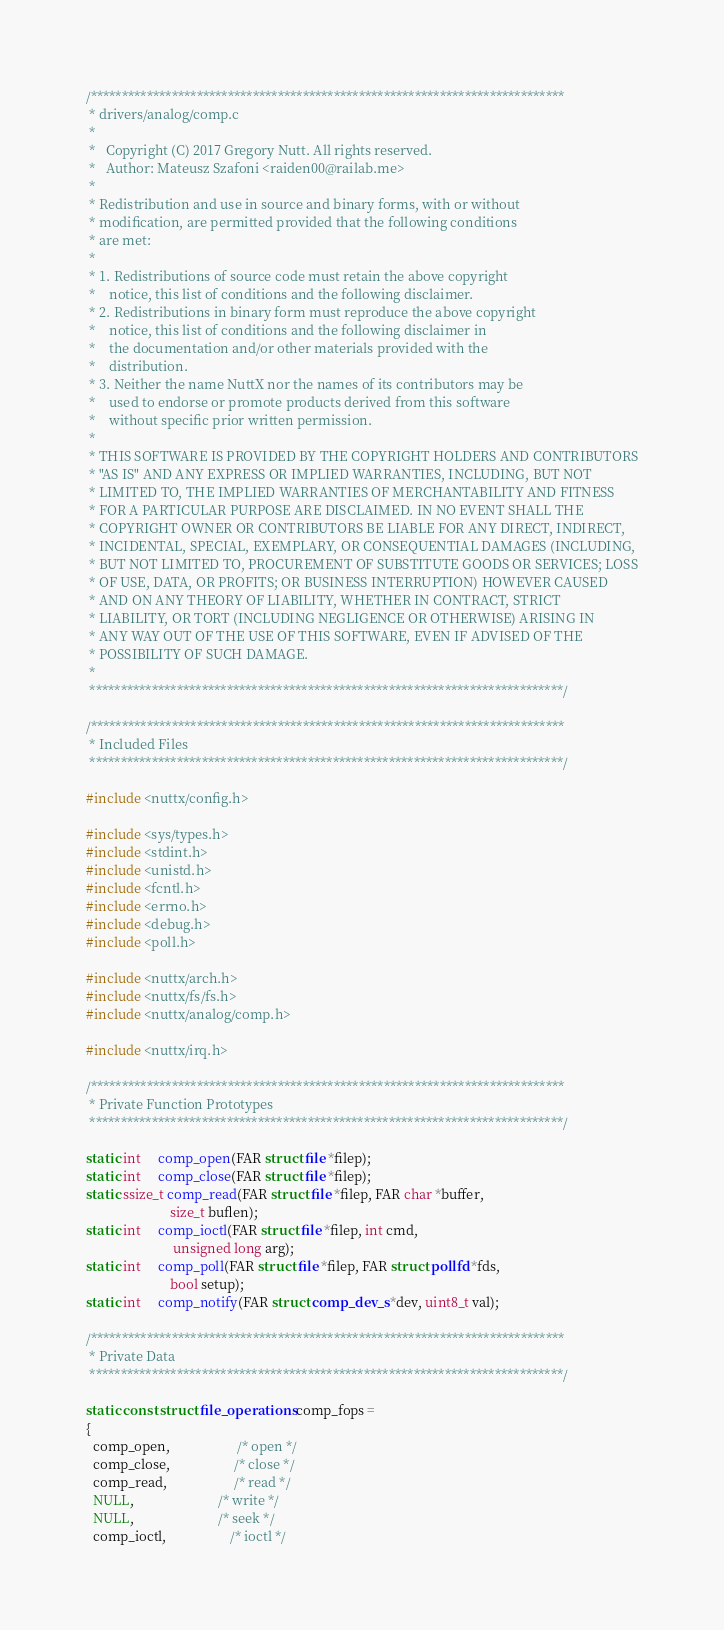Convert code to text. <code><loc_0><loc_0><loc_500><loc_500><_C_>/****************************************************************************
 * drivers/analog/comp.c
 *
 *   Copyright (C) 2017 Gregory Nutt. All rights reserved.
 *   Author: Mateusz Szafoni <raiden00@railab.me>
 *
 * Redistribution and use in source and binary forms, with or without
 * modification, are permitted provided that the following conditions
 * are met:
 *
 * 1. Redistributions of source code must retain the above copyright
 *    notice, this list of conditions and the following disclaimer.
 * 2. Redistributions in binary form must reproduce the above copyright
 *    notice, this list of conditions and the following disclaimer in
 *    the documentation and/or other materials provided with the
 *    distribution.
 * 3. Neither the name NuttX nor the names of its contributors may be
 *    used to endorse or promote products derived from this software
 *    without specific prior written permission.
 *
 * THIS SOFTWARE IS PROVIDED BY THE COPYRIGHT HOLDERS AND CONTRIBUTORS
 * "AS IS" AND ANY EXPRESS OR IMPLIED WARRANTIES, INCLUDING, BUT NOT
 * LIMITED TO, THE IMPLIED WARRANTIES OF MERCHANTABILITY AND FITNESS
 * FOR A PARTICULAR PURPOSE ARE DISCLAIMED. IN NO EVENT SHALL THE
 * COPYRIGHT OWNER OR CONTRIBUTORS BE LIABLE FOR ANY DIRECT, INDIRECT,
 * INCIDENTAL, SPECIAL, EXEMPLARY, OR CONSEQUENTIAL DAMAGES (INCLUDING,
 * BUT NOT LIMITED TO, PROCUREMENT OF SUBSTITUTE GOODS OR SERVICES; LOSS
 * OF USE, DATA, OR PROFITS; OR BUSINESS INTERRUPTION) HOWEVER CAUSED
 * AND ON ANY THEORY OF LIABILITY, WHETHER IN CONTRACT, STRICT
 * LIABILITY, OR TORT (INCLUDING NEGLIGENCE OR OTHERWISE) ARISING IN
 * ANY WAY OUT OF THE USE OF THIS SOFTWARE, EVEN IF ADVISED OF THE
 * POSSIBILITY OF SUCH DAMAGE.
 *
 ****************************************************************************/

/****************************************************************************
 * Included Files
 ****************************************************************************/

#include <nuttx/config.h>

#include <sys/types.h>
#include <stdint.h>
#include <unistd.h>
#include <fcntl.h>
#include <errno.h>
#include <debug.h>
#include <poll.h>

#include <nuttx/arch.h>
#include <nuttx/fs/fs.h>
#include <nuttx/analog/comp.h>

#include <nuttx/irq.h>

/****************************************************************************
 * Private Function Prototypes
 ****************************************************************************/

static int     comp_open(FAR struct file *filep);
static int     comp_close(FAR struct file *filep);
static ssize_t comp_read(FAR struct file *filep, FAR char *buffer,
                         size_t buflen);
static int     comp_ioctl(FAR struct file *filep, int cmd,
                          unsigned long arg);
static int     comp_poll(FAR struct file *filep, FAR struct pollfd *fds,
                         bool setup);
static int     comp_notify(FAR struct comp_dev_s *dev, uint8_t val);

/****************************************************************************
 * Private Data
 ****************************************************************************/

static const struct file_operations comp_fops =
{
  comp_open,                    /* open */
  comp_close,                   /* close */
  comp_read,                    /* read */
  NULL,                         /* write */
  NULL,                         /* seek */
  comp_ioctl,                   /* ioctl */</code> 